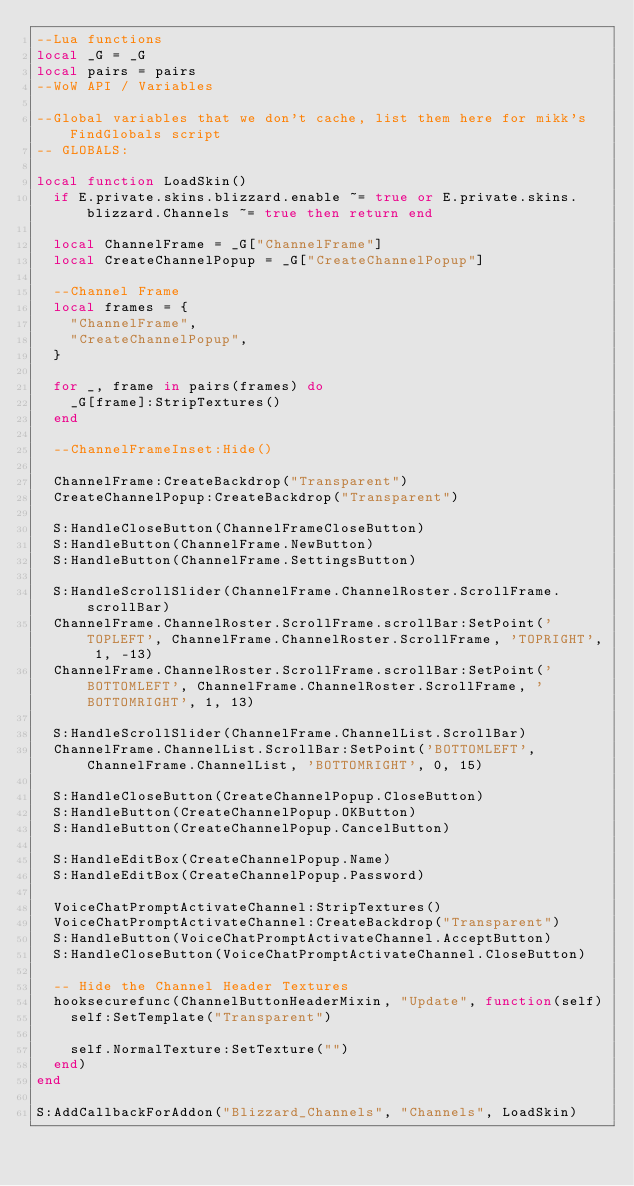<code> <loc_0><loc_0><loc_500><loc_500><_Lua_>--Lua functions
local _G = _G
local pairs = pairs
--WoW API / Variables

--Global variables that we don't cache, list them here for mikk's FindGlobals script
-- GLOBALS:

local function LoadSkin()
	if E.private.skins.blizzard.enable ~= true or E.private.skins.blizzard.Channels ~= true then return end

	local ChannelFrame = _G["ChannelFrame"]
	local CreateChannelPopup = _G["CreateChannelPopup"]

	--Channel Frame
	local frames = {
		"ChannelFrame",
		"CreateChannelPopup",
	}

	for _, frame in pairs(frames) do
		_G[frame]:StripTextures()
	end

	--ChannelFrameInset:Hide()

	ChannelFrame:CreateBackdrop("Transparent")
	CreateChannelPopup:CreateBackdrop("Transparent")

	S:HandleCloseButton(ChannelFrameCloseButton)
	S:HandleButton(ChannelFrame.NewButton)
	S:HandleButton(ChannelFrame.SettingsButton)

	S:HandleScrollSlider(ChannelFrame.ChannelRoster.ScrollFrame.scrollBar)
	ChannelFrame.ChannelRoster.ScrollFrame.scrollBar:SetPoint('TOPLEFT', ChannelFrame.ChannelRoster.ScrollFrame, 'TOPRIGHT', 1, -13)
	ChannelFrame.ChannelRoster.ScrollFrame.scrollBar:SetPoint('BOTTOMLEFT', ChannelFrame.ChannelRoster.ScrollFrame, 'BOTTOMRIGHT', 1, 13)

	S:HandleScrollSlider(ChannelFrame.ChannelList.ScrollBar)
	ChannelFrame.ChannelList.ScrollBar:SetPoint('BOTTOMLEFT', ChannelFrame.ChannelList, 'BOTTOMRIGHT', 0, 15)

	S:HandleCloseButton(CreateChannelPopup.CloseButton)
	S:HandleButton(CreateChannelPopup.OKButton)
	S:HandleButton(CreateChannelPopup.CancelButton)

	S:HandleEditBox(CreateChannelPopup.Name)
	S:HandleEditBox(CreateChannelPopup.Password)

	VoiceChatPromptActivateChannel:StripTextures()
	VoiceChatPromptActivateChannel:CreateBackdrop("Transparent")
	S:HandleButton(VoiceChatPromptActivateChannel.AcceptButton)
	S:HandleCloseButton(VoiceChatPromptActivateChannel.CloseButton)

	-- Hide the Channel Header Textures
	hooksecurefunc(ChannelButtonHeaderMixin, "Update", function(self)
		self:SetTemplate("Transparent")

		self.NormalTexture:SetTexture("")
	end)
end

S:AddCallbackForAddon("Blizzard_Channels", "Channels", LoadSkin)
</code> 